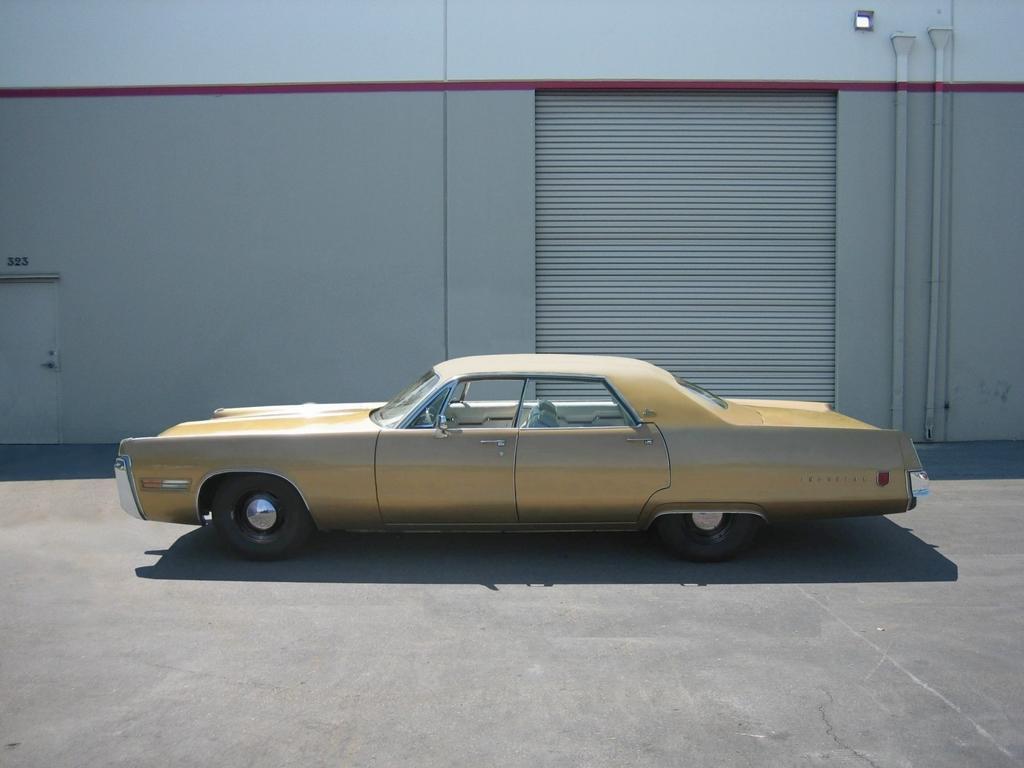Please provide a concise description of this image. In this picture there is a car. At the back there is a building and there are pipes on the wall. On the left side of the image there is a door and there are numbers on the wall. At the bottom there is a road and there is a shadow of the car on the road. 